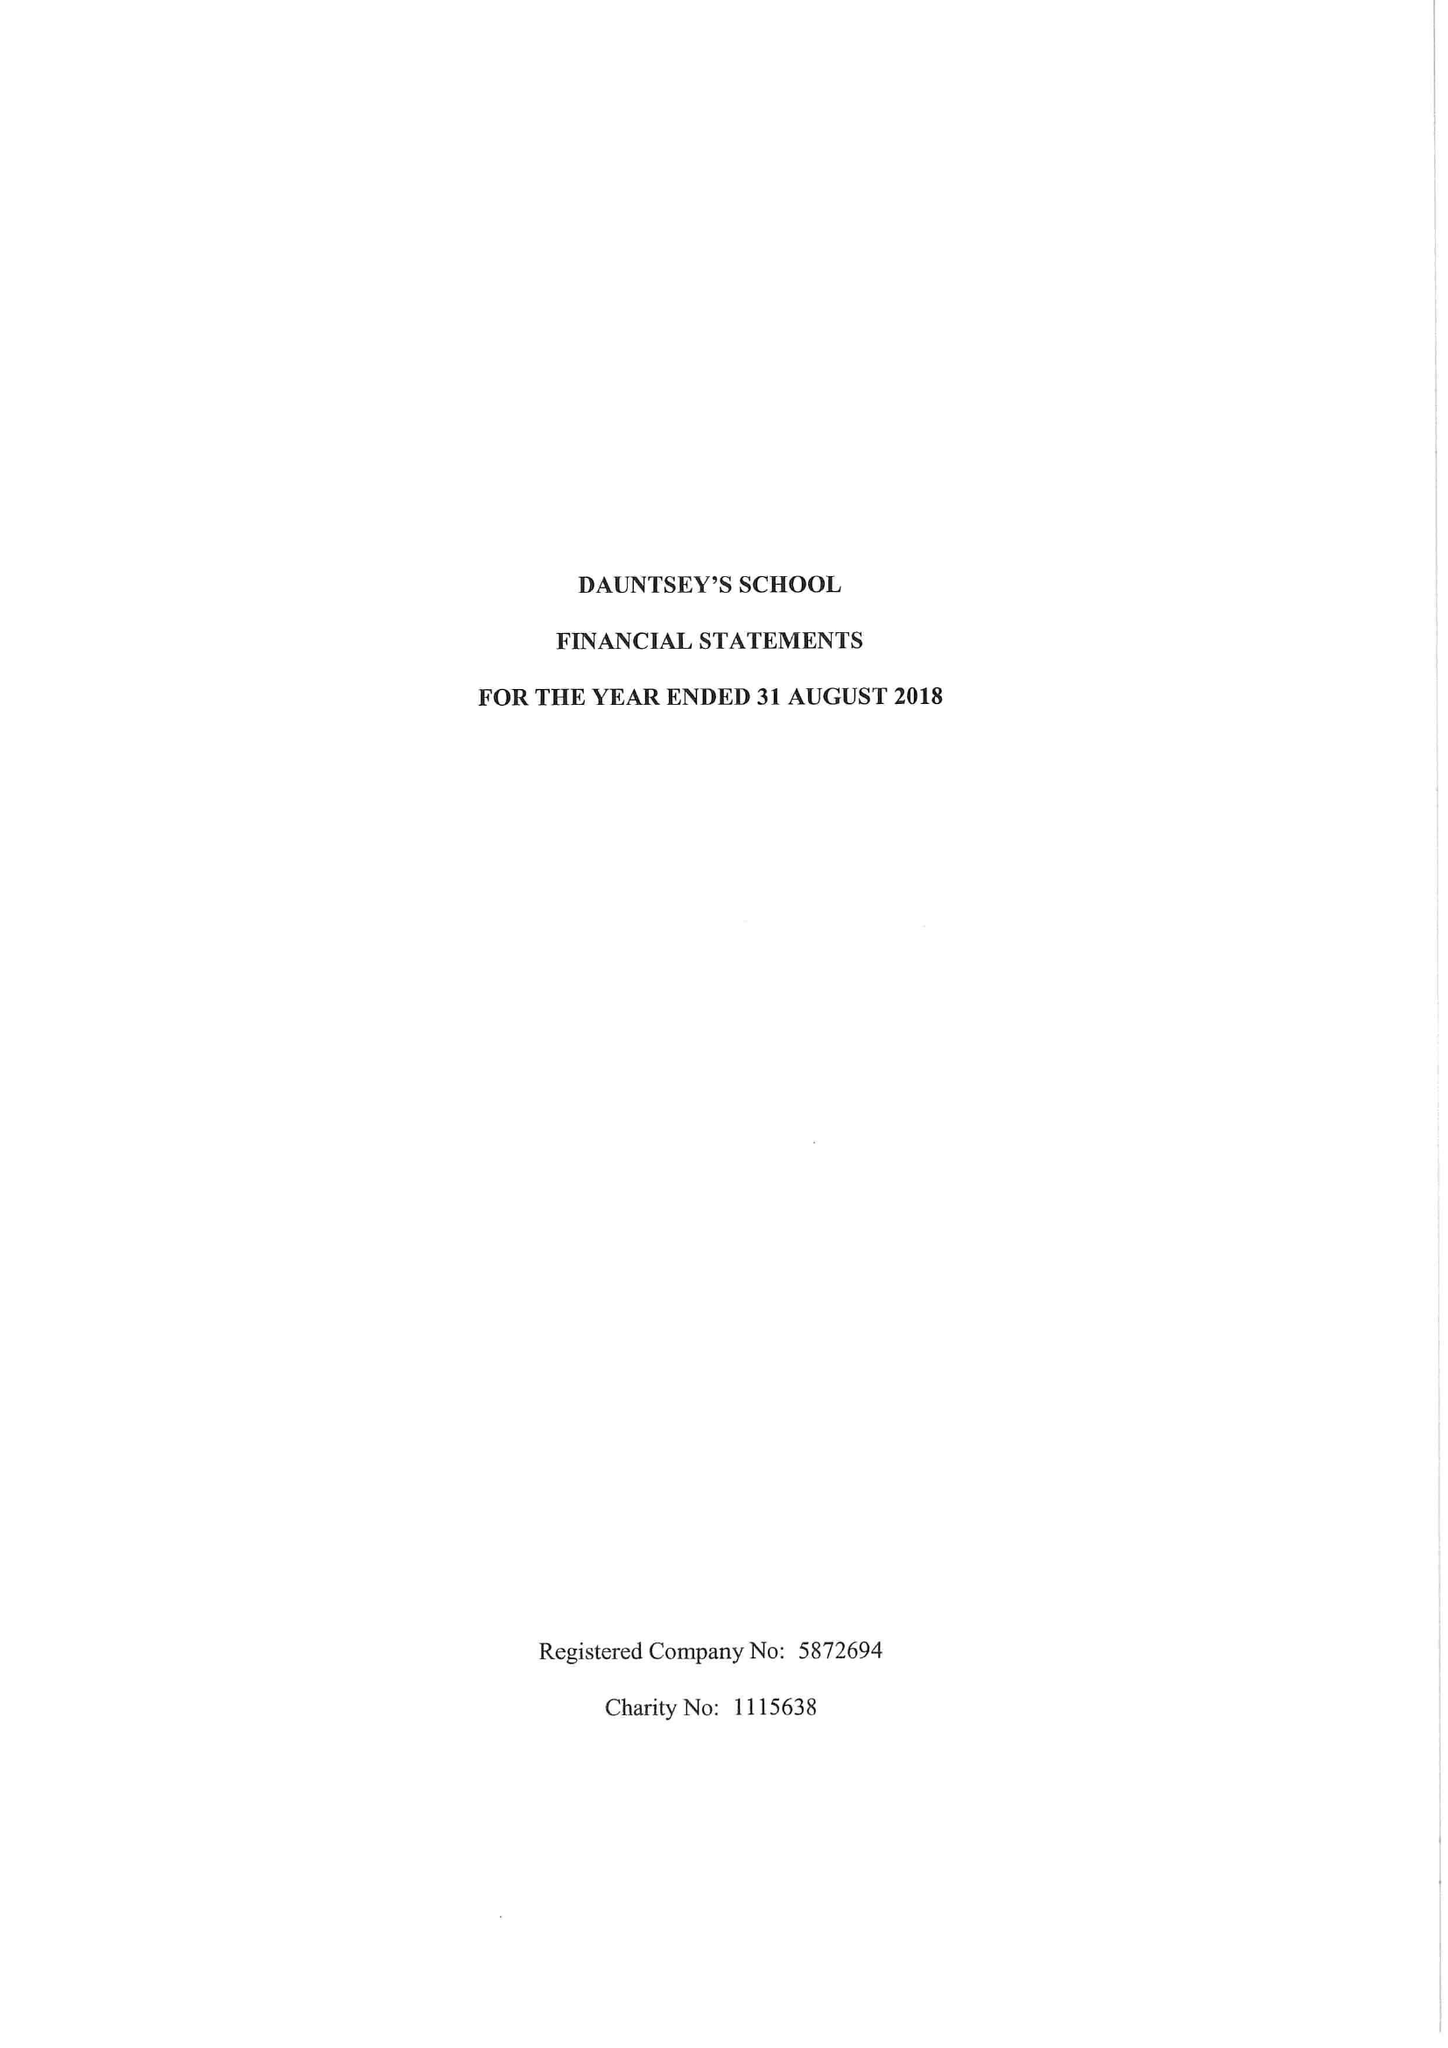What is the value for the charity_name?
Answer the question using a single word or phrase. Dauntsey's School 